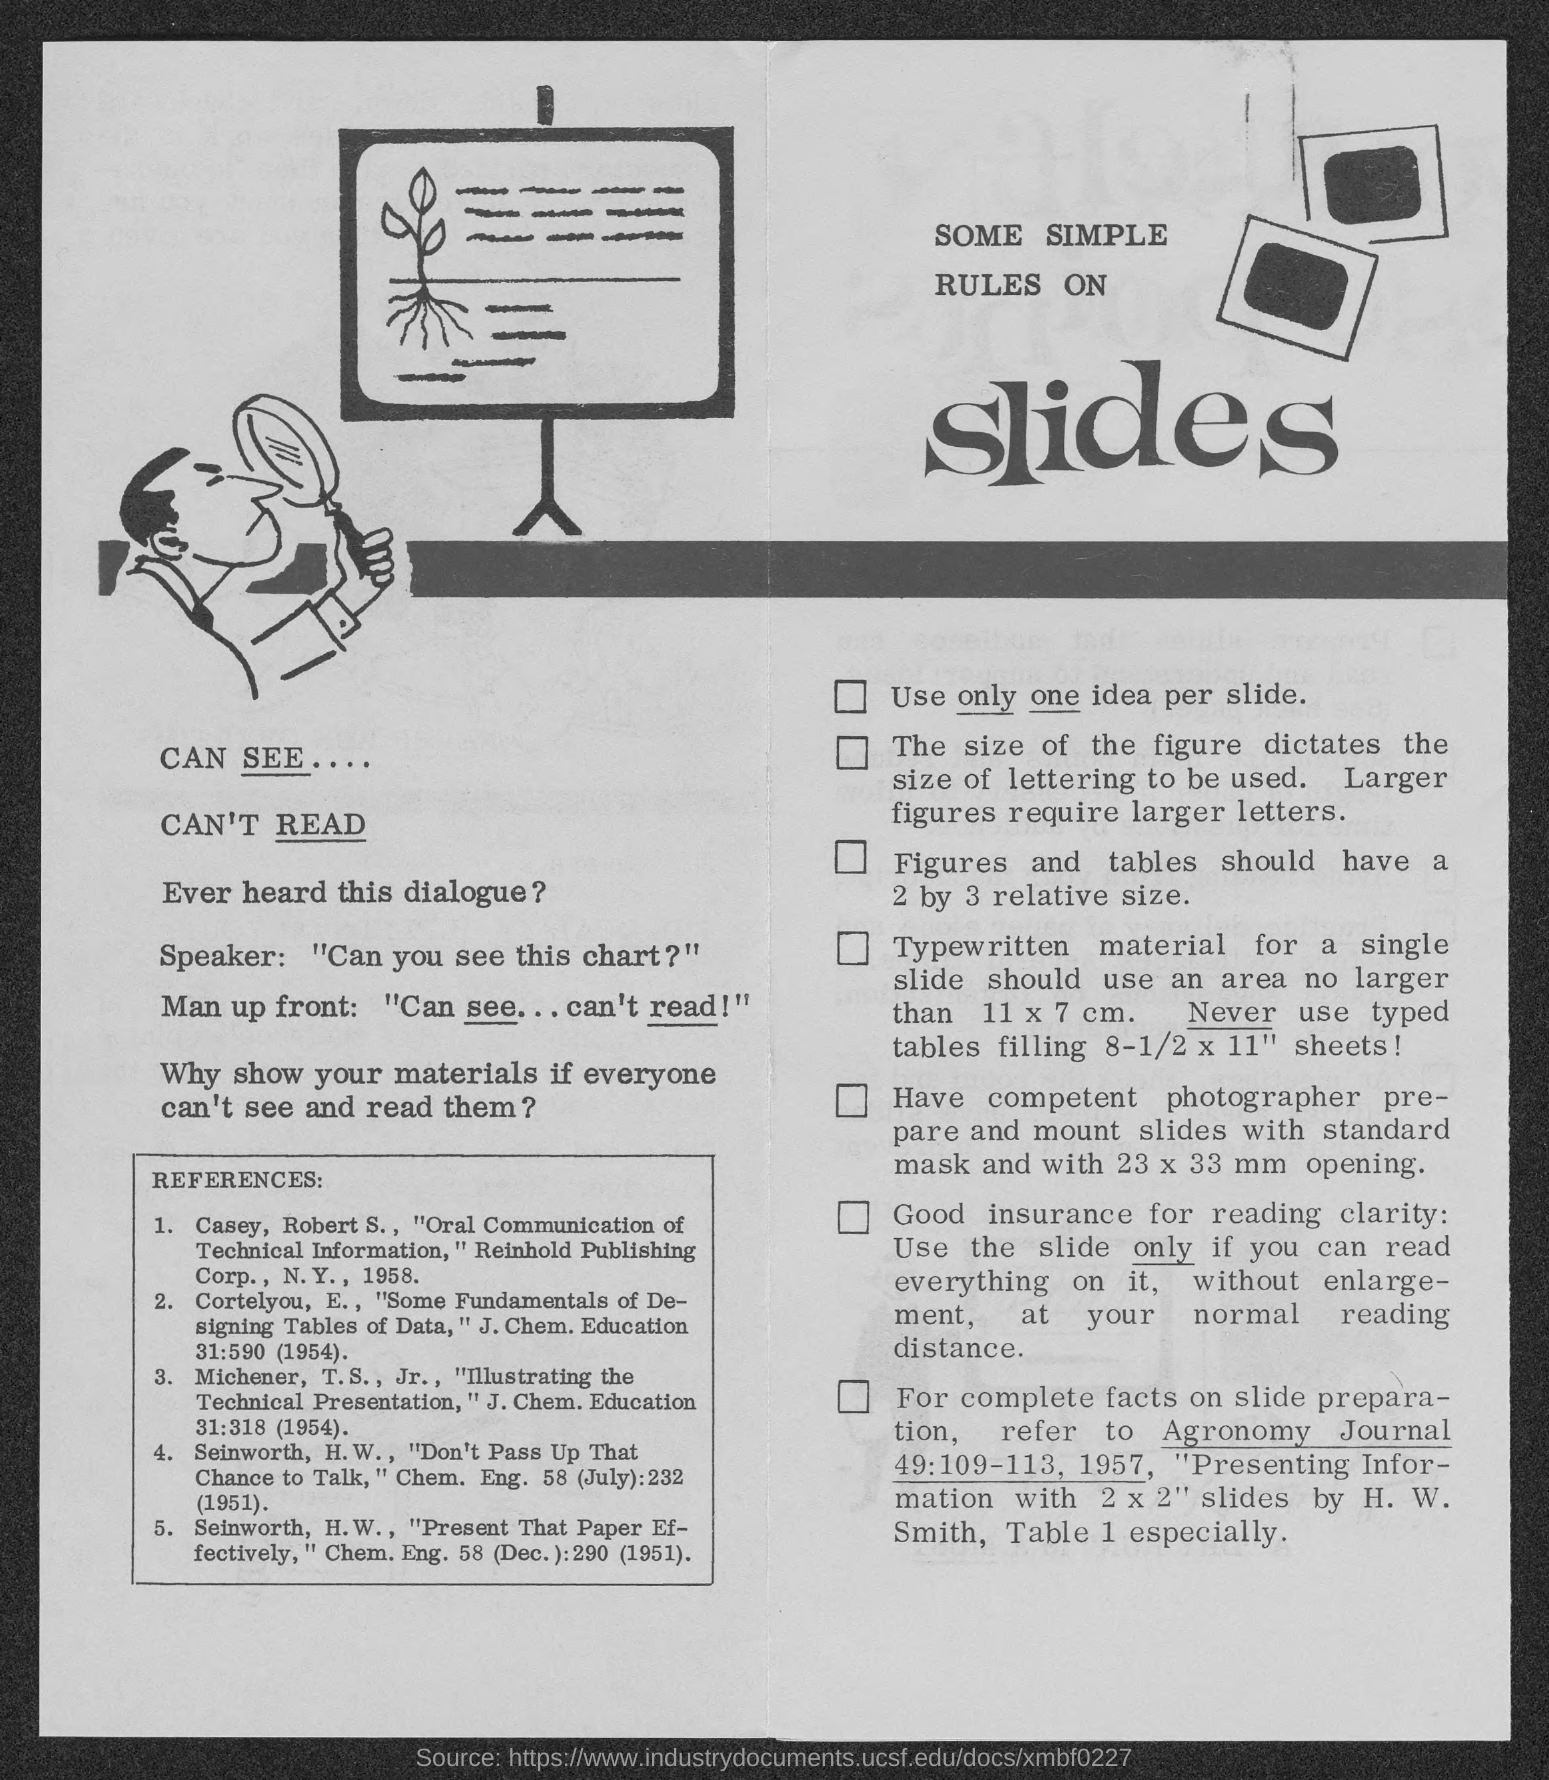Draw attention to some important aspects in this diagram. The title of the document is 'What is the Title of the document? Some simple rules on slides.' 